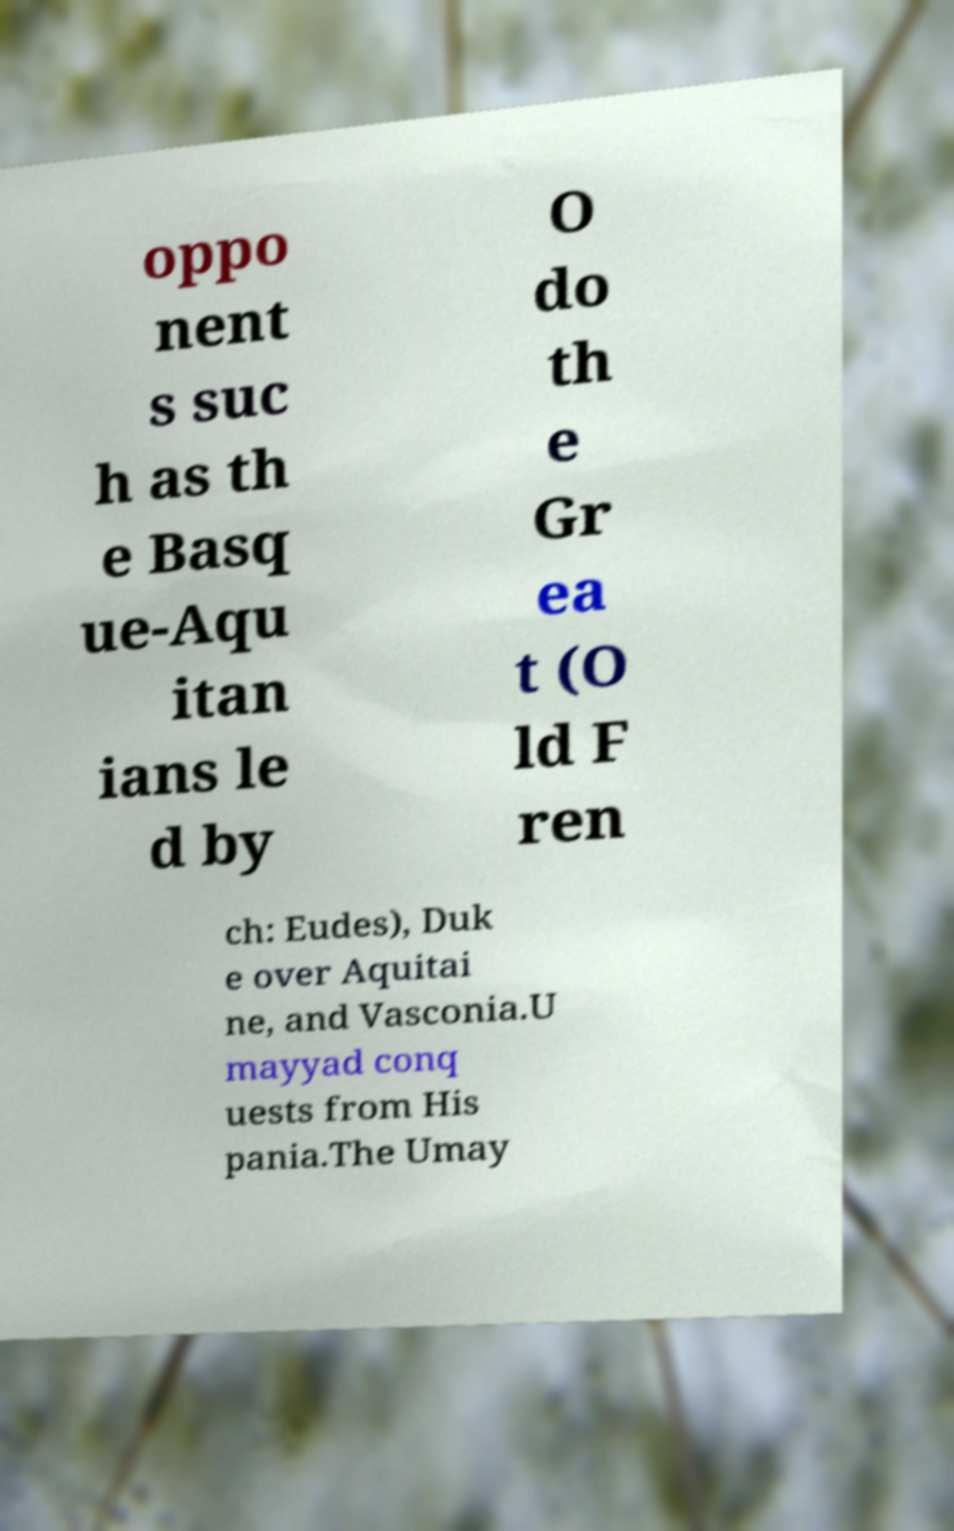Could you assist in decoding the text presented in this image and type it out clearly? oppo nent s suc h as th e Basq ue-Aqu itan ians le d by O do th e Gr ea t (O ld F ren ch: Eudes), Duk e over Aquitai ne, and Vasconia.U mayyad conq uests from His pania.The Umay 